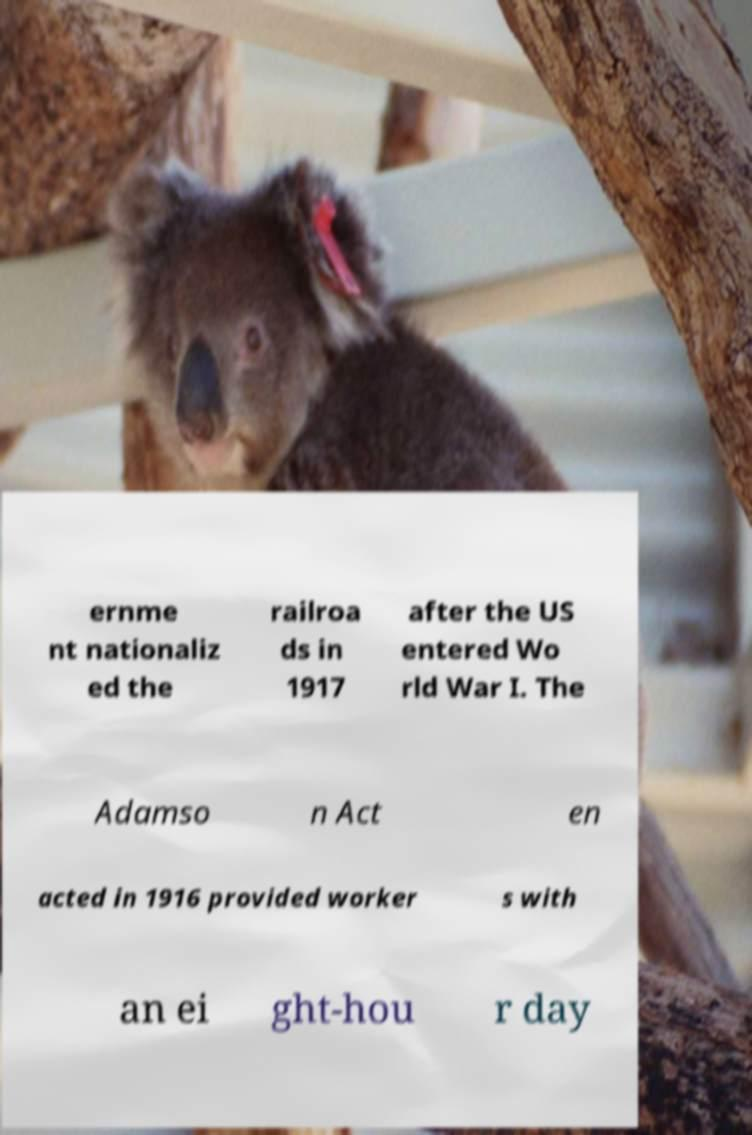Please read and relay the text visible in this image. What does it say? ernme nt nationaliz ed the railroa ds in 1917 after the US entered Wo rld War I. The Adamso n Act en acted in 1916 provided worker s with an ei ght-hou r day 